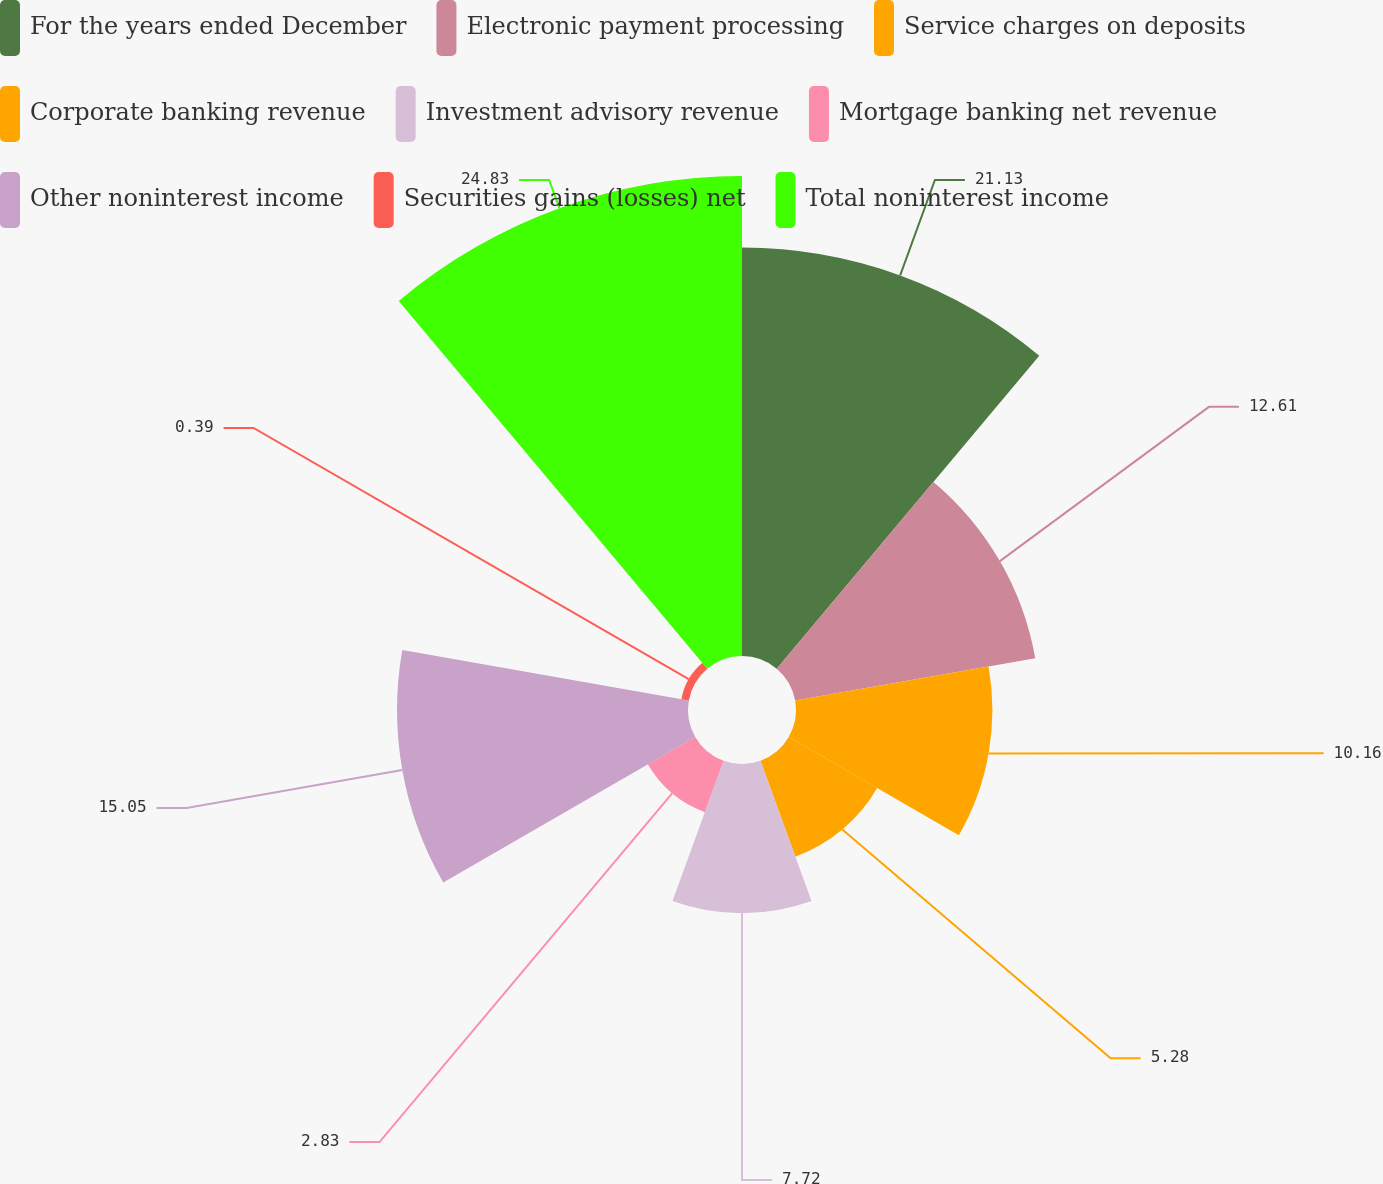Convert chart. <chart><loc_0><loc_0><loc_500><loc_500><pie_chart><fcel>For the years ended December<fcel>Electronic payment processing<fcel>Service charges on deposits<fcel>Corporate banking revenue<fcel>Investment advisory revenue<fcel>Mortgage banking net revenue<fcel>Other noninterest income<fcel>Securities gains (losses) net<fcel>Total noninterest income<nl><fcel>21.13%<fcel>12.61%<fcel>10.16%<fcel>5.28%<fcel>7.72%<fcel>2.83%<fcel>15.05%<fcel>0.39%<fcel>24.83%<nl></chart> 